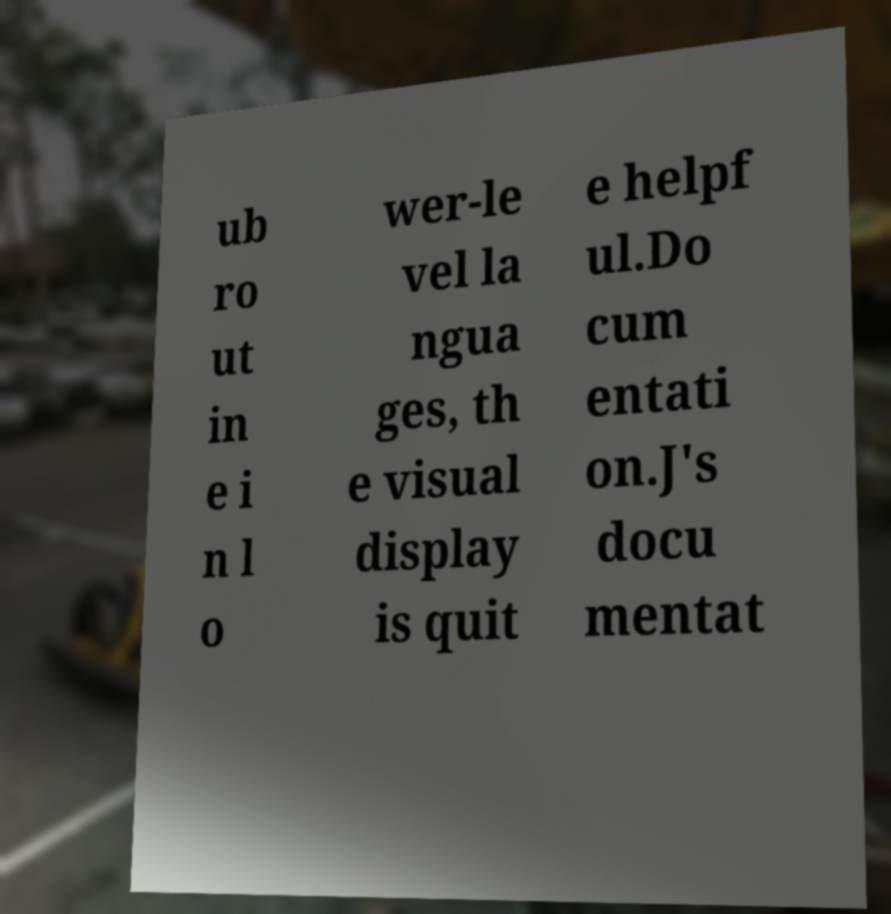There's text embedded in this image that I need extracted. Can you transcribe it verbatim? ub ro ut in e i n l o wer-le vel la ngua ges, th e visual display is quit e helpf ul.Do cum entati on.J's docu mentat 